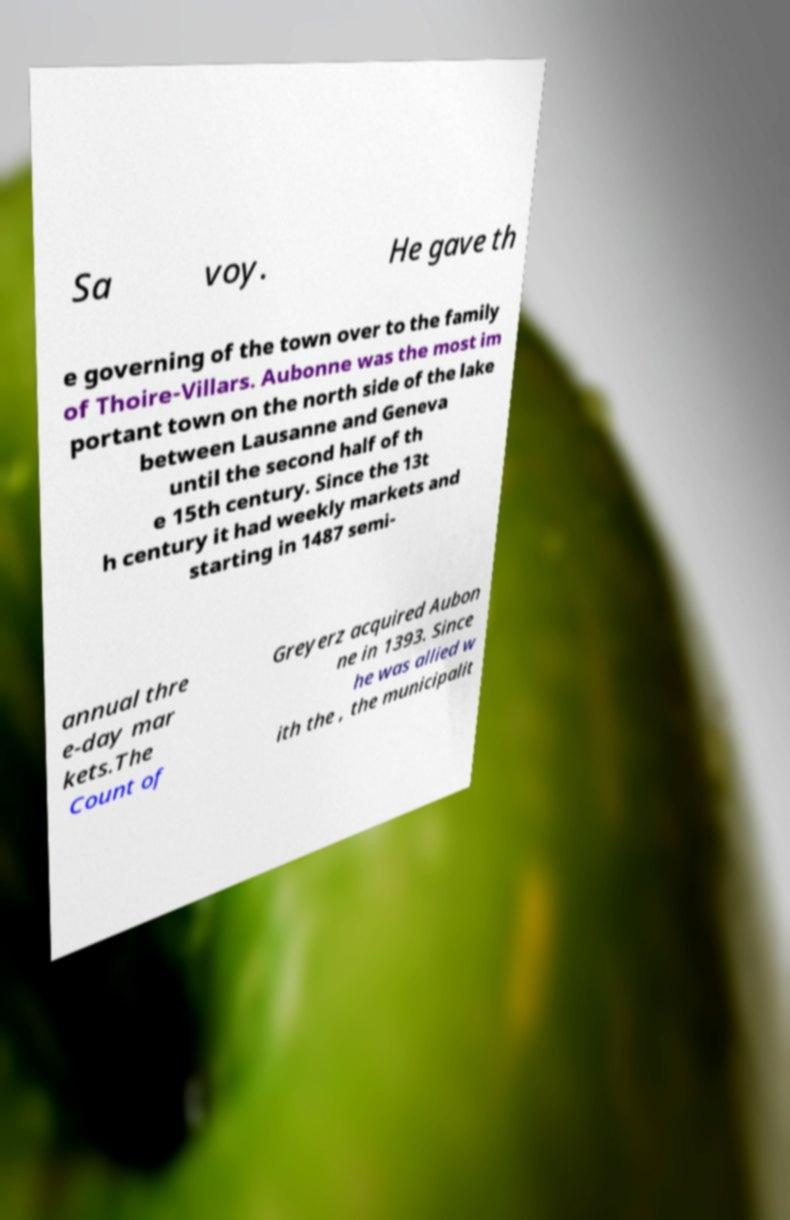Can you accurately transcribe the text from the provided image for me? Sa voy. He gave th e governing of the town over to the family of Thoire-Villars. Aubonne was the most im portant town on the north side of the lake between Lausanne and Geneva until the second half of th e 15th century. Since the 13t h century it had weekly markets and starting in 1487 semi- annual thre e-day mar kets.The Count of Greyerz acquired Aubon ne in 1393. Since he was allied w ith the , the municipalit 